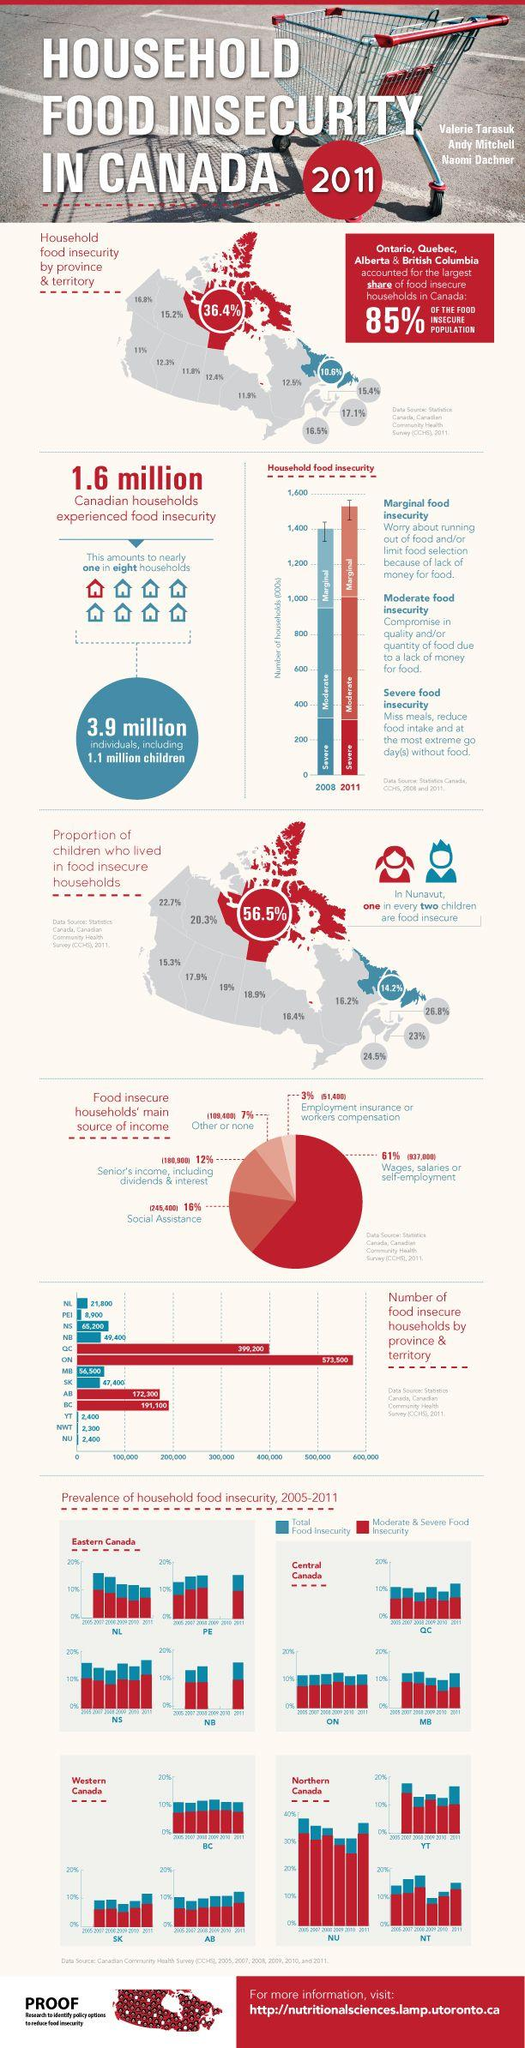Indicate a few pertinent items in this graphic. In Canada, four provinces accounted for the largest number of households experiencing food insecurity. According to the data, Quebec has the lowest percentage of food insecurity, followed by Ontario and Newfoundland & Labrador. However, it is important to note that food insecurity is a serious issue that affects communities across the country, and more efforts are needed to address it. 